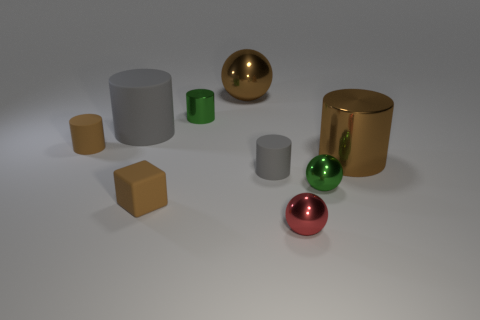Do the brown shiny cylinder and the brown rubber cylinder have the same size?
Make the answer very short. No. Is there anything else that is the same size as the red metallic ball?
Offer a terse response. Yes. There is a large thing that is the same material as the big brown cylinder; what is its color?
Make the answer very short. Brown. Is the number of tiny red metallic spheres that are behind the large matte thing less than the number of metal objects in front of the small green sphere?
Your answer should be very brief. Yes. What number of large matte cylinders have the same color as the block?
Your answer should be very brief. 0. What is the material of the ball that is the same color as the tiny rubber cube?
Give a very brief answer. Metal. How many green metal things are both on the left side of the large sphere and in front of the tiny gray rubber thing?
Your answer should be very brief. 0. What material is the tiny brown object that is in front of the big object in front of the small brown matte cylinder?
Make the answer very short. Rubber. Are there any brown objects made of the same material as the tiny cube?
Your response must be concise. Yes. What material is the green sphere that is the same size as the brown block?
Make the answer very short. Metal. 